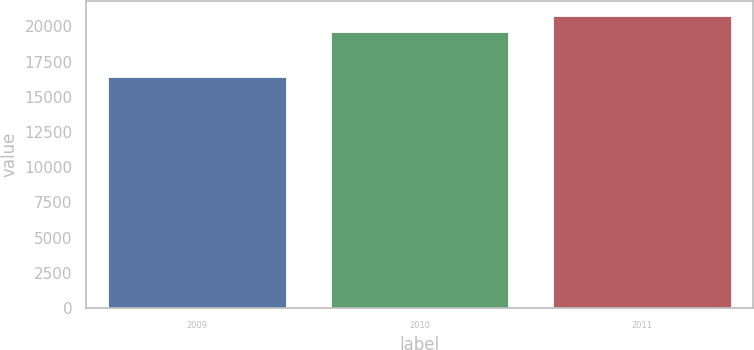<chart> <loc_0><loc_0><loc_500><loc_500><bar_chart><fcel>2009<fcel>2010<fcel>2011<nl><fcel>16412<fcel>19595<fcel>20747<nl></chart> 